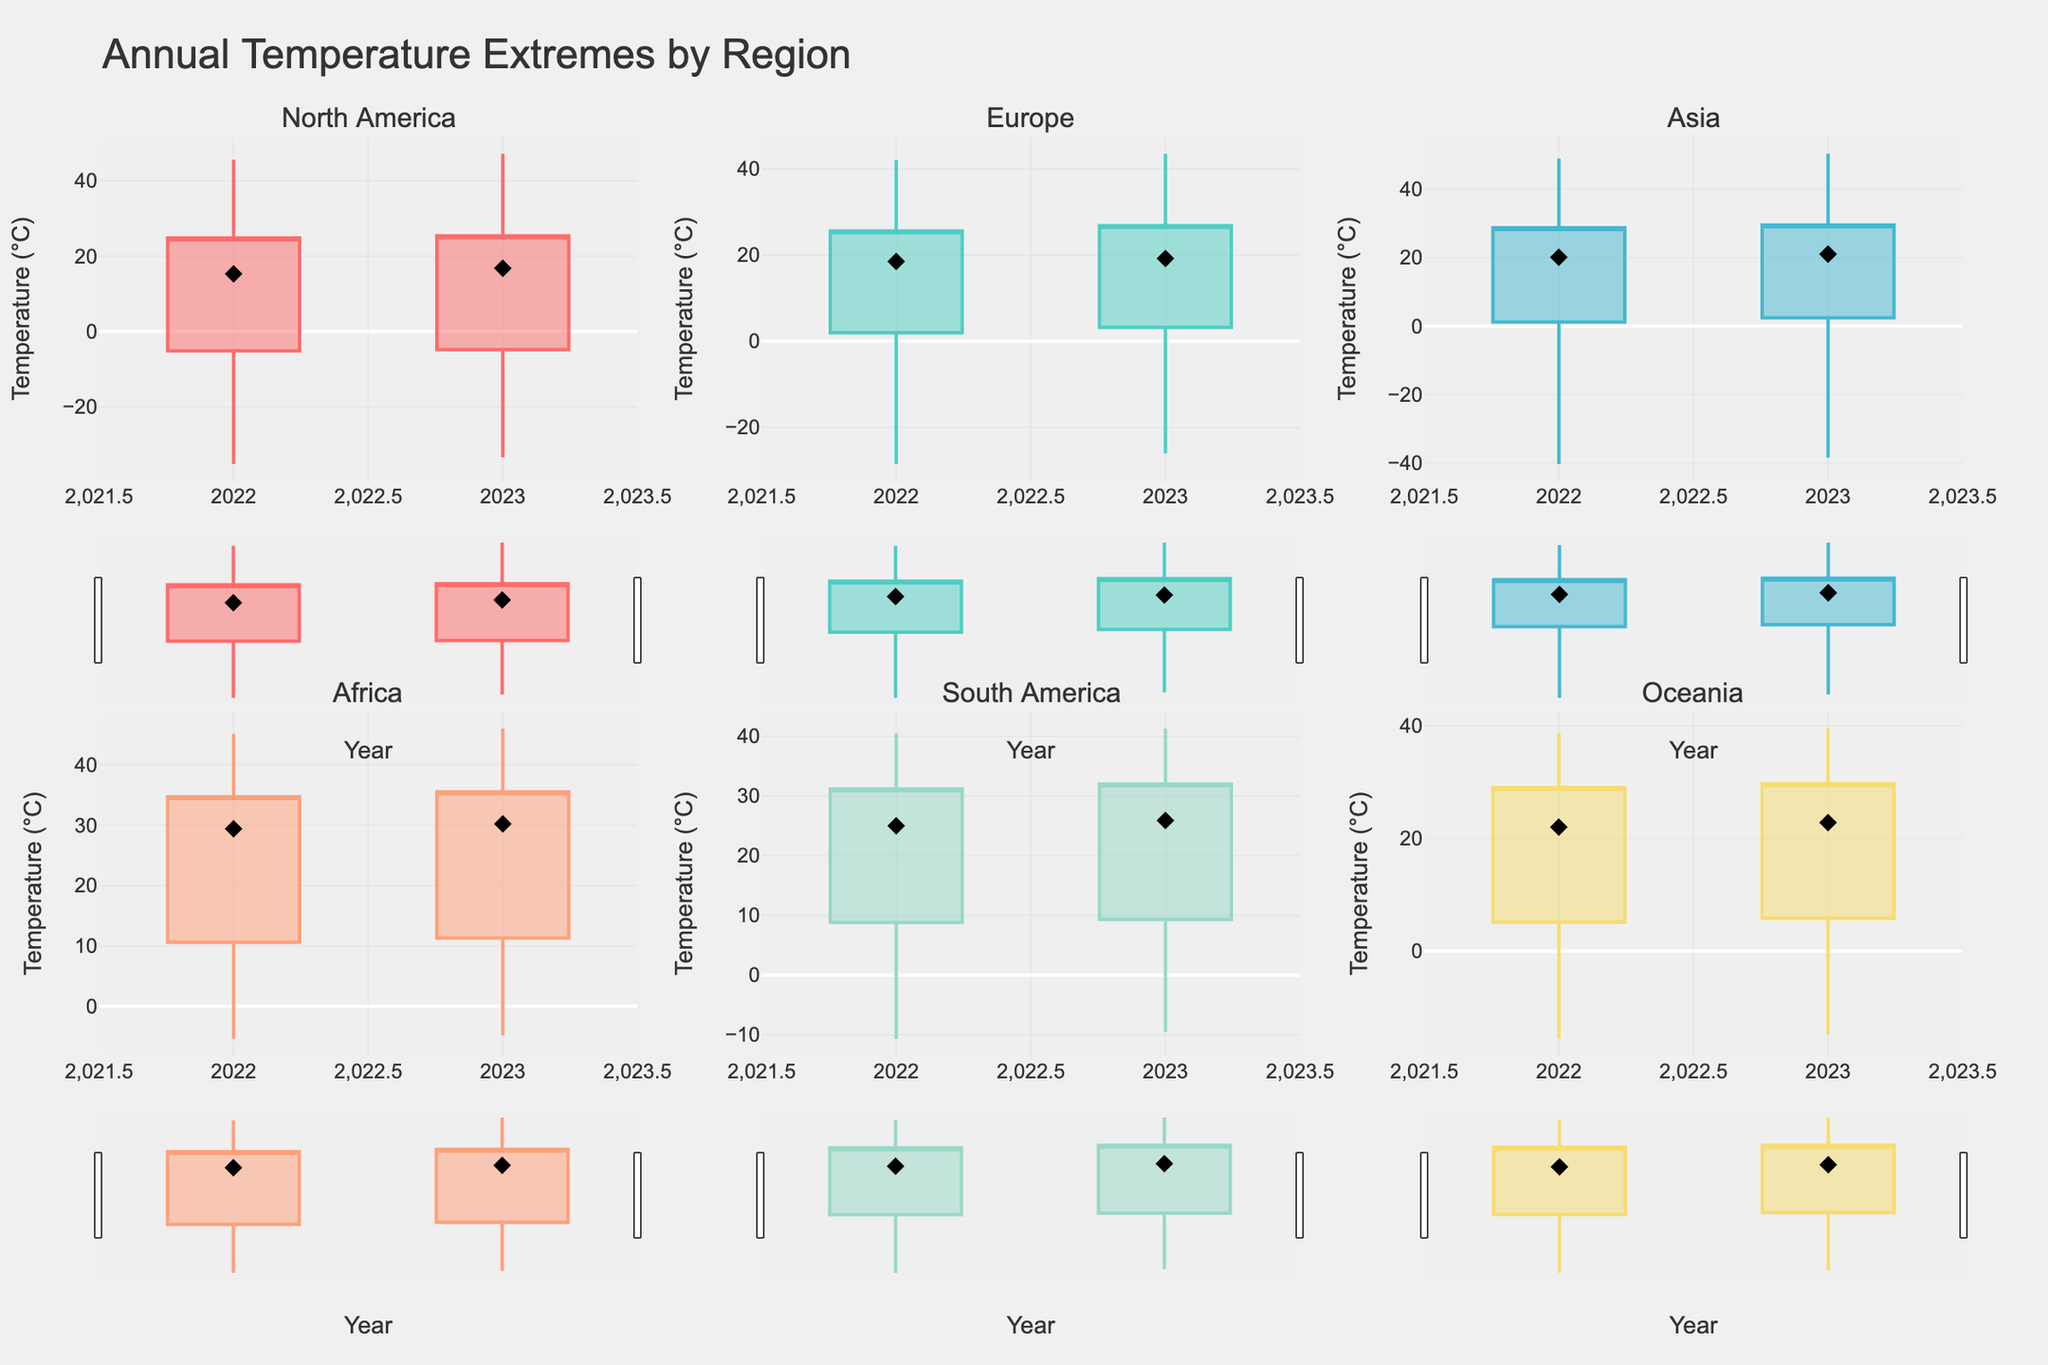What's the title of the figure? The title of the figure can be found at the top and it is labeled "Annual Temperature Extremes by Region".
Answer: Annual Temperature Extremes by Region How many regions are displayed in the figure? Each subplot title represents a region, and there are six subplot titles present. Thus, there are six regions displayed.
Answer: Six What is the minimum temperature recorded in North America in 2022? The minimum temperature is indicated by the lowest point of the candlestick for North America in 2022, which is -35.2°C.
Answer: -35.2°C What's the median temperature in Europe for 2023? The median temperature is marked by the black diamond symbol in the scatter plot for Europe in 2023, which is 19.2°C.
Answer: 19.2°C Which region has the highest maximum temperature in 2023? By comparing the maximum temperature, which is the topmost point of each candlestick, Asia has the highest maximum temperature in 2023 at 50.3°C.
Answer: Asia Compare the third quartile temperature of Africa in 2023 with South America in 2022. Which one is higher? The third quartile temperature is indicated by the top edge of the candlestick body. Africa in 2023 has a third quartile temperature of 35.5°C, while South America in 2022 has 31.2°C. Therefore, Africa's 2023 third quartile temperature is higher.
Answer: Africa in 2023 What's the temperature range in Oceania for 2022? The temperature range can be calculated by subtracting the minimum temperature from the maximum temperature for Oceania in 2022, which is 38.7°C - (-15.6°C) = 54.3°C.
Answer: 54.3°C Between 2022 and 2023, which year had a higher median temperature in North America? Comparing the black diamond markers for North America, 2023 has a median temperature of 16.8°C, which is higher than 2022's 15.3°C.
Answer: 2023 What's the interquartile range (IQR) for Asia in 2023? The IQR is calculated by subtracting the first quartile from the third quartile for Asia in 2023, which is 29.5°C - 2.4°C = 27.1°C.
Answer: 27.1°C 